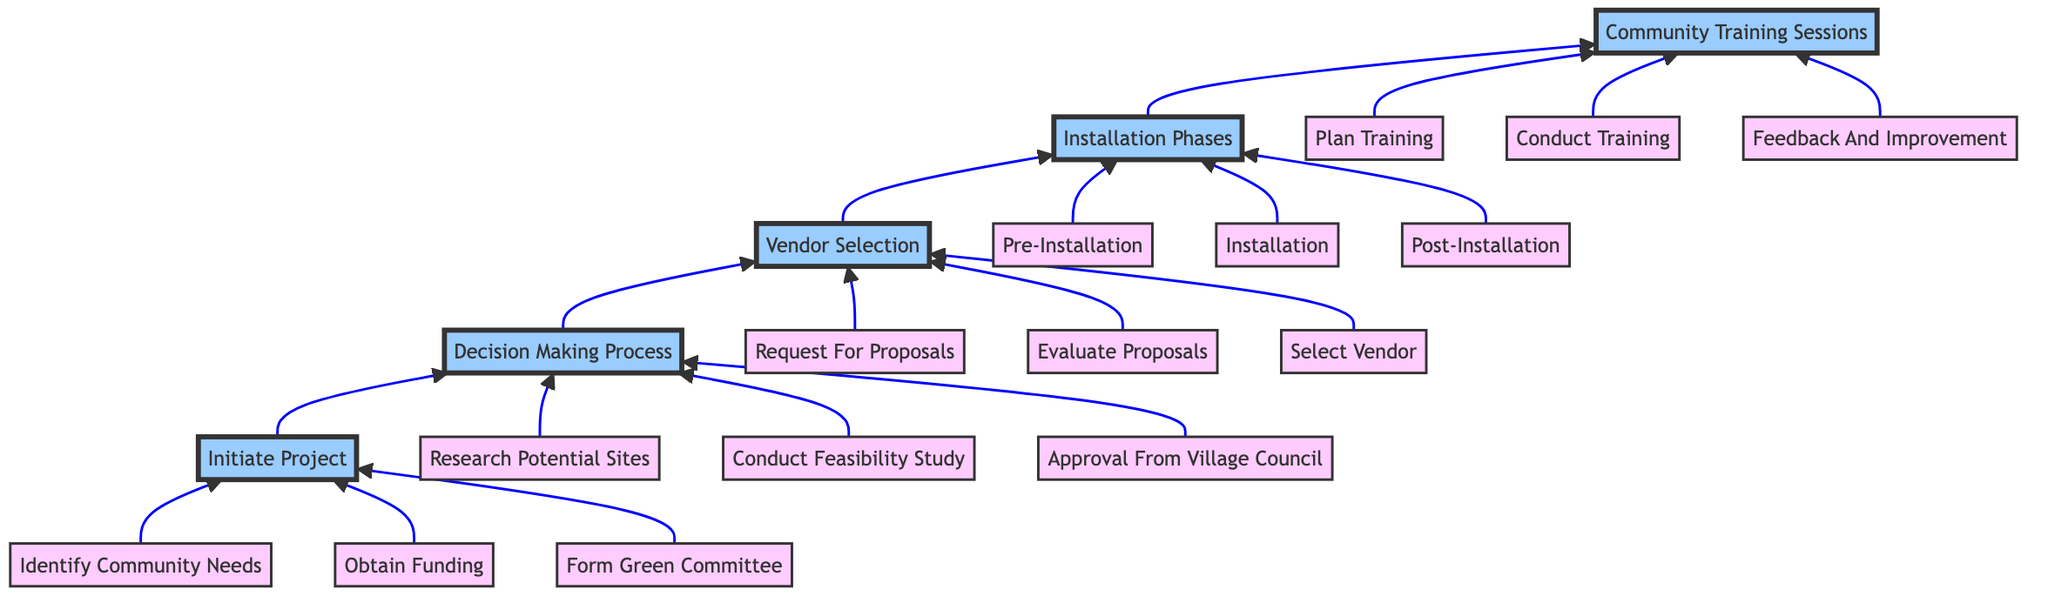What is the first phase in the flowchart? The first phase represented at the bottom of the flowchart is "Initiate Project," which starts the overall process.
Answer: Initiate Project How many subprocesses are under the Decision Making Process? The Decision Making Process contains three subprocesses: Research Potential Sites, Conduct Feasibility Study, and Approval From Village Council.
Answer: 3 Which subprocess comes after Vendor Selection in the flowchart? After Vendor Selection, the next subprocess in the flowchart is Installation Phases, indicating the progression from choosing a vendor to implementing the project.
Answer: Installation Phases What does E1 represent in the Community Training Sessions? E1 represents "Plan Training," which is the first step in the Community Training Sessions subprocess and indicates scheduling training activities.
Answer: Plan Training What is required before installing solar panels according to the Installation Phases? According to the Installation Phases, "Pre-Installation" is required before actual installation, which involves inspecting and preparing the sites.
Answer: Pre-Installation Which subprocess includes collecting feedback from residents? The subprocess that includes collecting feedback from residents is "Identify Community Needs" under the Initiate Project phase.
Answer: Identify Community Needs How is the vendor selected in the Vendor Selection phase? Vendors are selected based on the evaluation criteria set during the "Evaluate Proposals" subprocess and finalized in "Select Vendor."
Answer: Based on evaluation criteria What action follows "Conduct Training" in the Community Training Sessions? Following "Conduct Training," the next action is "Feedback And Improvement," which implies gathering feedback to enhance future sessions.
Answer: Feedback And Improvement What type of committee is formed during the Initiate Project phase? A "Green Committee" is formed during the Initiate Project phase, focusing on environmental engagement and representation from public buildings.
Answer: Green Committee 